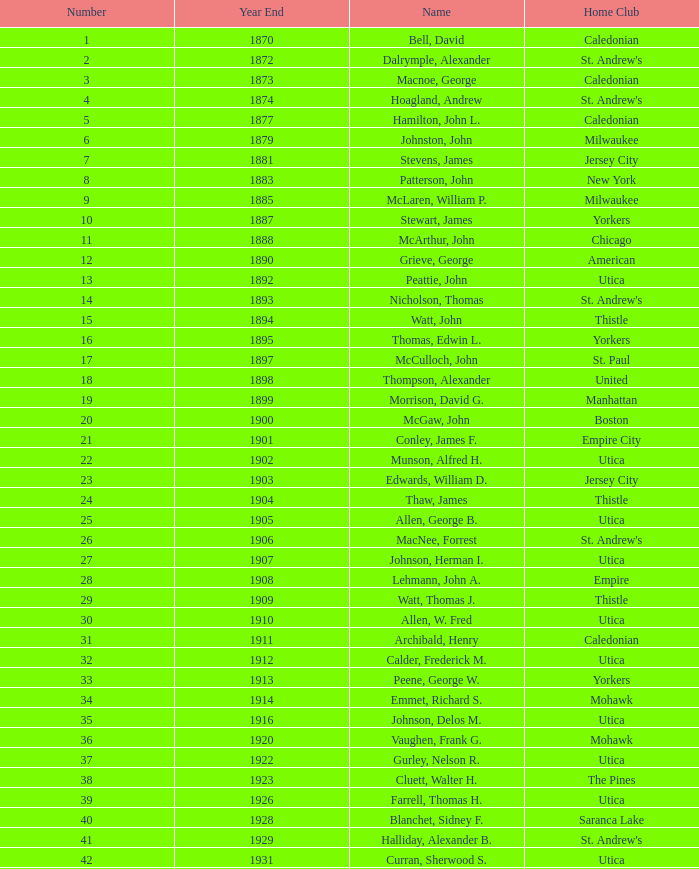Which Number has a Home Club of broomstones, and a Year End smaller than 1999? None. 